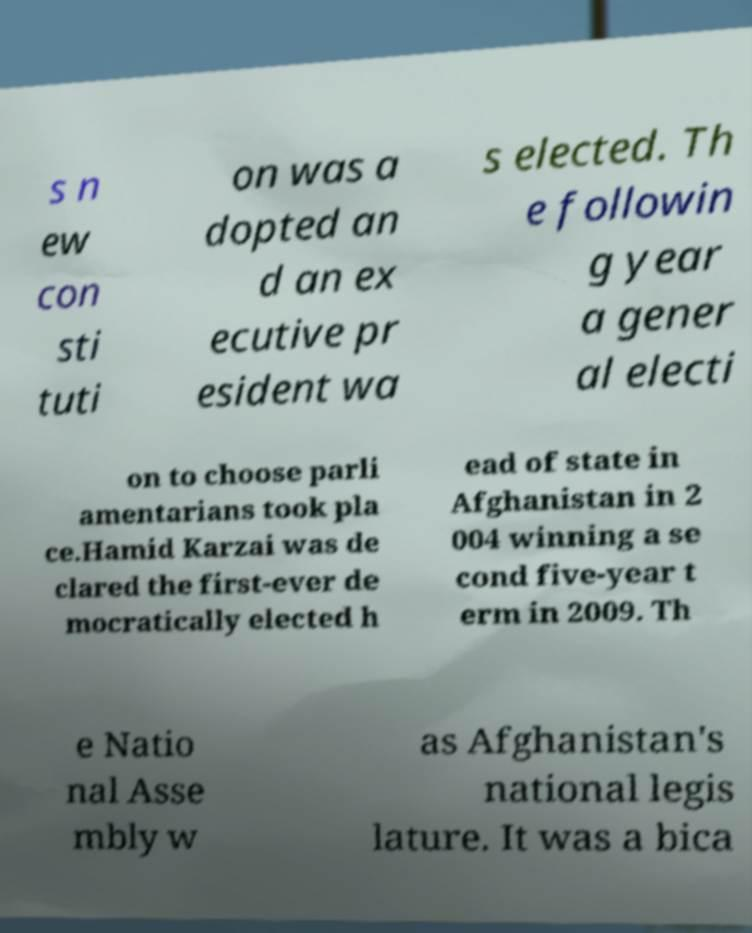I need the written content from this picture converted into text. Can you do that? s n ew con sti tuti on was a dopted an d an ex ecutive pr esident wa s elected. Th e followin g year a gener al electi on to choose parli amentarians took pla ce.Hamid Karzai was de clared the first-ever de mocratically elected h ead of state in Afghanistan in 2 004 winning a se cond five-year t erm in 2009. Th e Natio nal Asse mbly w as Afghanistan's national legis lature. It was a bica 